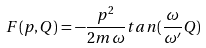Convert formula to latex. <formula><loc_0><loc_0><loc_500><loc_500>F ( p , Q ) = - \frac { p ^ { 2 } } { 2 m \omega } t a n ( \frac { \omega } { \omega ^ { \prime } } Q )</formula> 